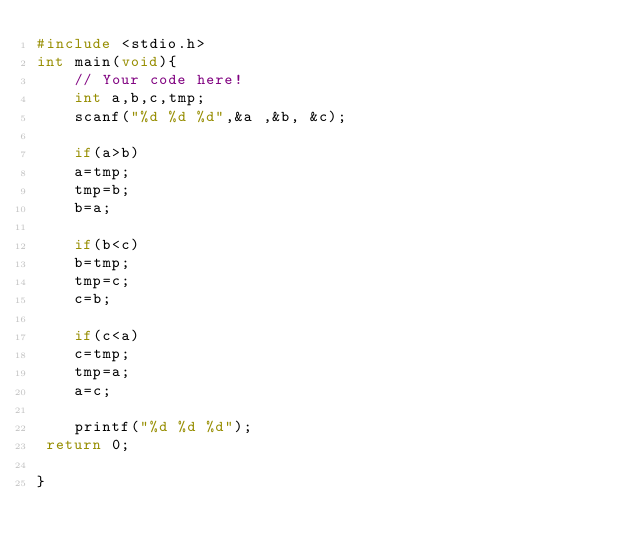<code> <loc_0><loc_0><loc_500><loc_500><_C_>#include <stdio.h>
int main(void){
    // Your code here!
    int a,b,c,tmp;
    scanf("%d %d %d",&a ,&b, &c);
    
    if(a>b)
    a=tmp;
    tmp=b;
    b=a;
    
    if(b<c)
    b=tmp;
    tmp=c;
    c=b;
    
    if(c<a)
    c=tmp;
    tmp=a;
    a=c;
    
    printf("%d %d %d");
 return 0;
 
}

</code> 